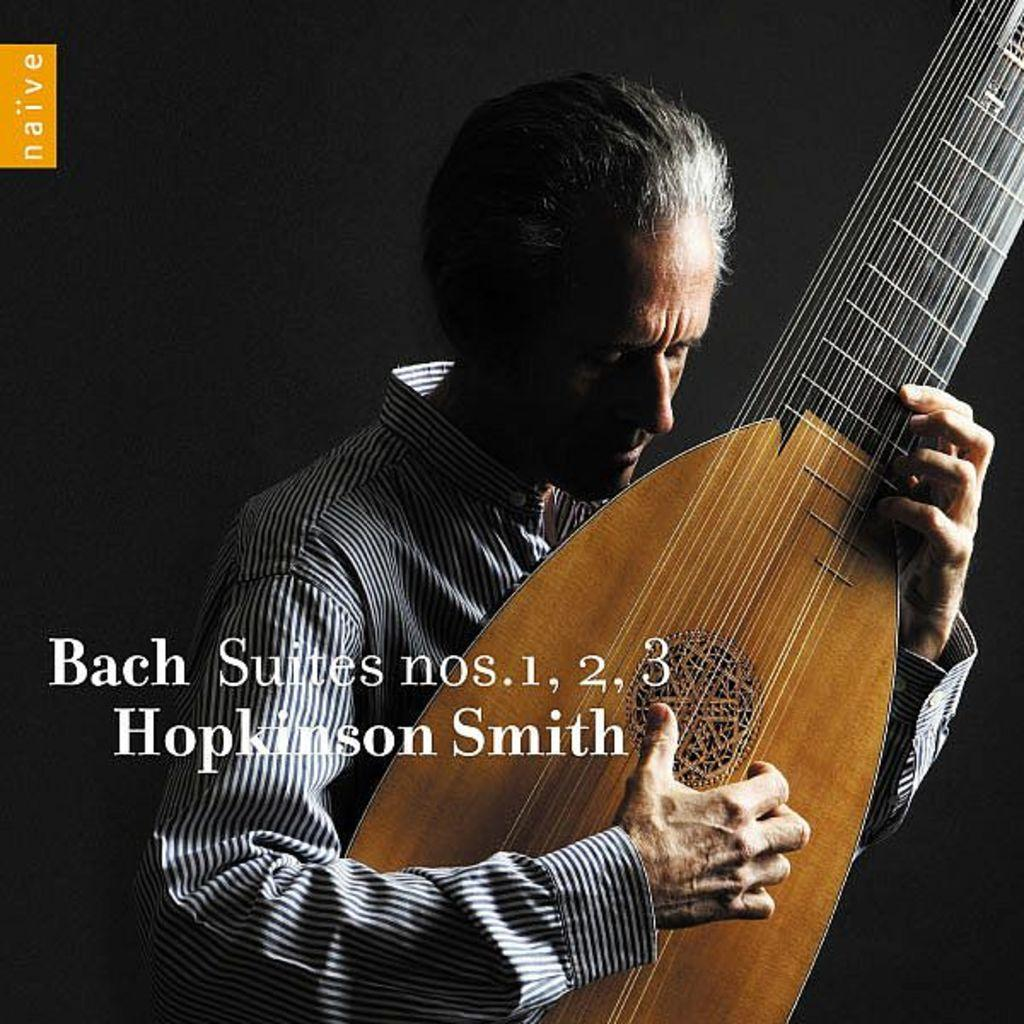Who is the main subject in the image? There is a man in the image. What is the man wearing? The man is wearing a black and white shirt. What is the man holding in the image? The man is holding a guitar. What is the man doing with the guitar? The man is playing the guitar. What can be seen in the middle of the image? There is text written in the middle of the image. What type of liquid is being poured out of the guitar in the image? There is no liquid being poured out of the guitar in the image; the man is playing the guitar. Can you see a dog playing with the man in the image? There is no dog present in the image; it features a man playing a guitar. 